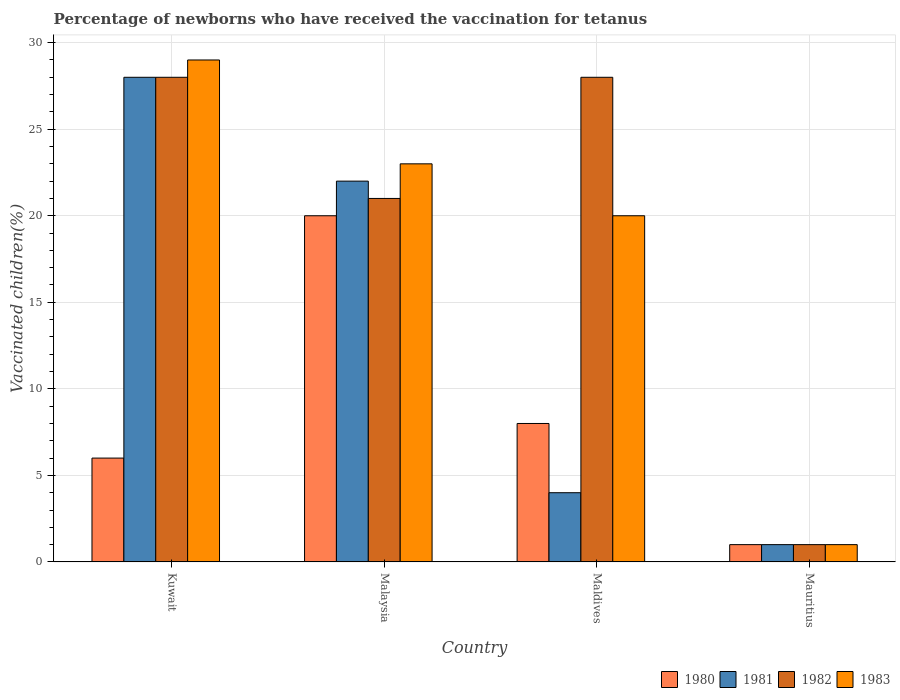How many different coloured bars are there?
Make the answer very short. 4. How many groups of bars are there?
Ensure brevity in your answer.  4. Are the number of bars on each tick of the X-axis equal?
Offer a very short reply. Yes. What is the label of the 1st group of bars from the left?
Your answer should be compact. Kuwait. In how many cases, is the number of bars for a given country not equal to the number of legend labels?
Ensure brevity in your answer.  0. What is the percentage of vaccinated children in 1982 in Mauritius?
Your answer should be compact. 1. In which country was the percentage of vaccinated children in 1981 maximum?
Make the answer very short. Kuwait. In which country was the percentage of vaccinated children in 1982 minimum?
Offer a terse response. Mauritius. What is the total percentage of vaccinated children in 1980 in the graph?
Ensure brevity in your answer.  35. What is the difference between the percentage of vaccinated children in 1982 in Kuwait and that in Maldives?
Your answer should be compact. 0. What is the average percentage of vaccinated children in 1980 per country?
Your answer should be very brief. 8.75. In how many countries, is the percentage of vaccinated children in 1981 greater than 27 %?
Ensure brevity in your answer.  1. What is the ratio of the percentage of vaccinated children in 1980 in Maldives to that in Mauritius?
Offer a terse response. 8. Is the percentage of vaccinated children in 1980 in Malaysia less than that in Maldives?
Give a very brief answer. No. What is the difference between the highest and the second highest percentage of vaccinated children in 1983?
Give a very brief answer. -9. Is the sum of the percentage of vaccinated children in 1982 in Malaysia and Mauritius greater than the maximum percentage of vaccinated children in 1981 across all countries?
Your answer should be compact. No. Is it the case that in every country, the sum of the percentage of vaccinated children in 1981 and percentage of vaccinated children in 1983 is greater than the percentage of vaccinated children in 1980?
Provide a short and direct response. Yes. How many legend labels are there?
Keep it short and to the point. 4. How are the legend labels stacked?
Keep it short and to the point. Horizontal. What is the title of the graph?
Give a very brief answer. Percentage of newborns who have received the vaccination for tetanus. What is the label or title of the Y-axis?
Provide a short and direct response. Vaccinated children(%). What is the Vaccinated children(%) in 1980 in Kuwait?
Offer a terse response. 6. What is the Vaccinated children(%) in 1980 in Malaysia?
Offer a very short reply. 20. What is the Vaccinated children(%) in 1981 in Maldives?
Your answer should be compact. 4. What is the Vaccinated children(%) of 1980 in Mauritius?
Offer a terse response. 1. What is the Vaccinated children(%) of 1982 in Mauritius?
Offer a terse response. 1. What is the Vaccinated children(%) in 1983 in Mauritius?
Your answer should be very brief. 1. Across all countries, what is the maximum Vaccinated children(%) of 1981?
Your answer should be very brief. 28. Across all countries, what is the minimum Vaccinated children(%) in 1980?
Keep it short and to the point. 1. Across all countries, what is the minimum Vaccinated children(%) of 1982?
Offer a very short reply. 1. Across all countries, what is the minimum Vaccinated children(%) in 1983?
Offer a terse response. 1. What is the total Vaccinated children(%) of 1981 in the graph?
Make the answer very short. 55. What is the total Vaccinated children(%) in 1982 in the graph?
Offer a very short reply. 78. What is the total Vaccinated children(%) of 1983 in the graph?
Your answer should be very brief. 73. What is the difference between the Vaccinated children(%) in 1981 in Kuwait and that in Malaysia?
Your answer should be compact. 6. What is the difference between the Vaccinated children(%) in 1983 in Kuwait and that in Malaysia?
Your answer should be very brief. 6. What is the difference between the Vaccinated children(%) of 1981 in Kuwait and that in Maldives?
Your response must be concise. 24. What is the difference between the Vaccinated children(%) in 1982 in Kuwait and that in Maldives?
Ensure brevity in your answer.  0. What is the difference between the Vaccinated children(%) of 1980 in Kuwait and that in Mauritius?
Provide a short and direct response. 5. What is the difference between the Vaccinated children(%) of 1980 in Malaysia and that in Maldives?
Give a very brief answer. 12. What is the difference between the Vaccinated children(%) in 1981 in Malaysia and that in Mauritius?
Your answer should be compact. 21. What is the difference between the Vaccinated children(%) in 1983 in Malaysia and that in Mauritius?
Make the answer very short. 22. What is the difference between the Vaccinated children(%) in 1980 in Maldives and that in Mauritius?
Give a very brief answer. 7. What is the difference between the Vaccinated children(%) of 1982 in Maldives and that in Mauritius?
Your response must be concise. 27. What is the difference between the Vaccinated children(%) of 1983 in Maldives and that in Mauritius?
Offer a very short reply. 19. What is the difference between the Vaccinated children(%) of 1980 in Kuwait and the Vaccinated children(%) of 1983 in Malaysia?
Keep it short and to the point. -17. What is the difference between the Vaccinated children(%) of 1982 in Kuwait and the Vaccinated children(%) of 1983 in Malaysia?
Provide a short and direct response. 5. What is the difference between the Vaccinated children(%) of 1980 in Kuwait and the Vaccinated children(%) of 1981 in Maldives?
Give a very brief answer. 2. What is the difference between the Vaccinated children(%) of 1980 in Kuwait and the Vaccinated children(%) of 1982 in Maldives?
Keep it short and to the point. -22. What is the difference between the Vaccinated children(%) in 1980 in Kuwait and the Vaccinated children(%) in 1983 in Maldives?
Make the answer very short. -14. What is the difference between the Vaccinated children(%) of 1981 in Kuwait and the Vaccinated children(%) of 1982 in Maldives?
Provide a succinct answer. 0. What is the difference between the Vaccinated children(%) of 1980 in Kuwait and the Vaccinated children(%) of 1981 in Mauritius?
Your response must be concise. 5. What is the difference between the Vaccinated children(%) in 1980 in Kuwait and the Vaccinated children(%) in 1982 in Mauritius?
Your answer should be compact. 5. What is the difference between the Vaccinated children(%) in 1980 in Kuwait and the Vaccinated children(%) in 1983 in Mauritius?
Your answer should be compact. 5. What is the difference between the Vaccinated children(%) of 1981 in Kuwait and the Vaccinated children(%) of 1982 in Mauritius?
Offer a very short reply. 27. What is the difference between the Vaccinated children(%) of 1981 in Kuwait and the Vaccinated children(%) of 1983 in Mauritius?
Your answer should be very brief. 27. What is the difference between the Vaccinated children(%) in 1980 in Malaysia and the Vaccinated children(%) in 1982 in Maldives?
Your response must be concise. -8. What is the difference between the Vaccinated children(%) in 1980 in Malaysia and the Vaccinated children(%) in 1983 in Maldives?
Your answer should be very brief. 0. What is the difference between the Vaccinated children(%) in 1981 in Malaysia and the Vaccinated children(%) in 1983 in Maldives?
Keep it short and to the point. 2. What is the difference between the Vaccinated children(%) in 1980 in Malaysia and the Vaccinated children(%) in 1981 in Mauritius?
Make the answer very short. 19. What is the difference between the Vaccinated children(%) of 1982 in Malaysia and the Vaccinated children(%) of 1983 in Mauritius?
Offer a very short reply. 20. What is the difference between the Vaccinated children(%) of 1980 in Maldives and the Vaccinated children(%) of 1983 in Mauritius?
Provide a short and direct response. 7. What is the difference between the Vaccinated children(%) in 1981 in Maldives and the Vaccinated children(%) in 1982 in Mauritius?
Keep it short and to the point. 3. What is the difference between the Vaccinated children(%) in 1982 in Maldives and the Vaccinated children(%) in 1983 in Mauritius?
Make the answer very short. 27. What is the average Vaccinated children(%) in 1980 per country?
Your answer should be compact. 8.75. What is the average Vaccinated children(%) in 1981 per country?
Your answer should be compact. 13.75. What is the average Vaccinated children(%) in 1983 per country?
Your answer should be very brief. 18.25. What is the difference between the Vaccinated children(%) of 1980 and Vaccinated children(%) of 1981 in Kuwait?
Ensure brevity in your answer.  -22. What is the difference between the Vaccinated children(%) of 1980 and Vaccinated children(%) of 1982 in Kuwait?
Offer a terse response. -22. What is the difference between the Vaccinated children(%) in 1980 and Vaccinated children(%) in 1981 in Malaysia?
Offer a very short reply. -2. What is the difference between the Vaccinated children(%) of 1980 and Vaccinated children(%) of 1983 in Malaysia?
Your response must be concise. -3. What is the difference between the Vaccinated children(%) in 1980 and Vaccinated children(%) in 1982 in Maldives?
Ensure brevity in your answer.  -20. What is the difference between the Vaccinated children(%) of 1980 and Vaccinated children(%) of 1983 in Maldives?
Give a very brief answer. -12. What is the difference between the Vaccinated children(%) of 1981 and Vaccinated children(%) of 1982 in Maldives?
Make the answer very short. -24. What is the difference between the Vaccinated children(%) in 1980 and Vaccinated children(%) in 1981 in Mauritius?
Offer a terse response. 0. What is the difference between the Vaccinated children(%) in 1980 and Vaccinated children(%) in 1982 in Mauritius?
Provide a succinct answer. 0. What is the difference between the Vaccinated children(%) in 1981 and Vaccinated children(%) in 1982 in Mauritius?
Provide a succinct answer. 0. What is the difference between the Vaccinated children(%) of 1981 and Vaccinated children(%) of 1983 in Mauritius?
Provide a succinct answer. 0. What is the ratio of the Vaccinated children(%) of 1980 in Kuwait to that in Malaysia?
Make the answer very short. 0.3. What is the ratio of the Vaccinated children(%) of 1981 in Kuwait to that in Malaysia?
Keep it short and to the point. 1.27. What is the ratio of the Vaccinated children(%) of 1983 in Kuwait to that in Malaysia?
Provide a succinct answer. 1.26. What is the ratio of the Vaccinated children(%) of 1980 in Kuwait to that in Maldives?
Provide a succinct answer. 0.75. What is the ratio of the Vaccinated children(%) of 1981 in Kuwait to that in Maldives?
Ensure brevity in your answer.  7. What is the ratio of the Vaccinated children(%) of 1983 in Kuwait to that in Maldives?
Offer a terse response. 1.45. What is the ratio of the Vaccinated children(%) in 1980 in Malaysia to that in Maldives?
Offer a very short reply. 2.5. What is the ratio of the Vaccinated children(%) in 1982 in Malaysia to that in Maldives?
Give a very brief answer. 0.75. What is the ratio of the Vaccinated children(%) of 1983 in Malaysia to that in Maldives?
Your answer should be compact. 1.15. What is the difference between the highest and the second highest Vaccinated children(%) in 1981?
Ensure brevity in your answer.  6. What is the difference between the highest and the lowest Vaccinated children(%) in 1980?
Offer a terse response. 19. What is the difference between the highest and the lowest Vaccinated children(%) of 1981?
Provide a short and direct response. 27. What is the difference between the highest and the lowest Vaccinated children(%) of 1982?
Offer a terse response. 27. 